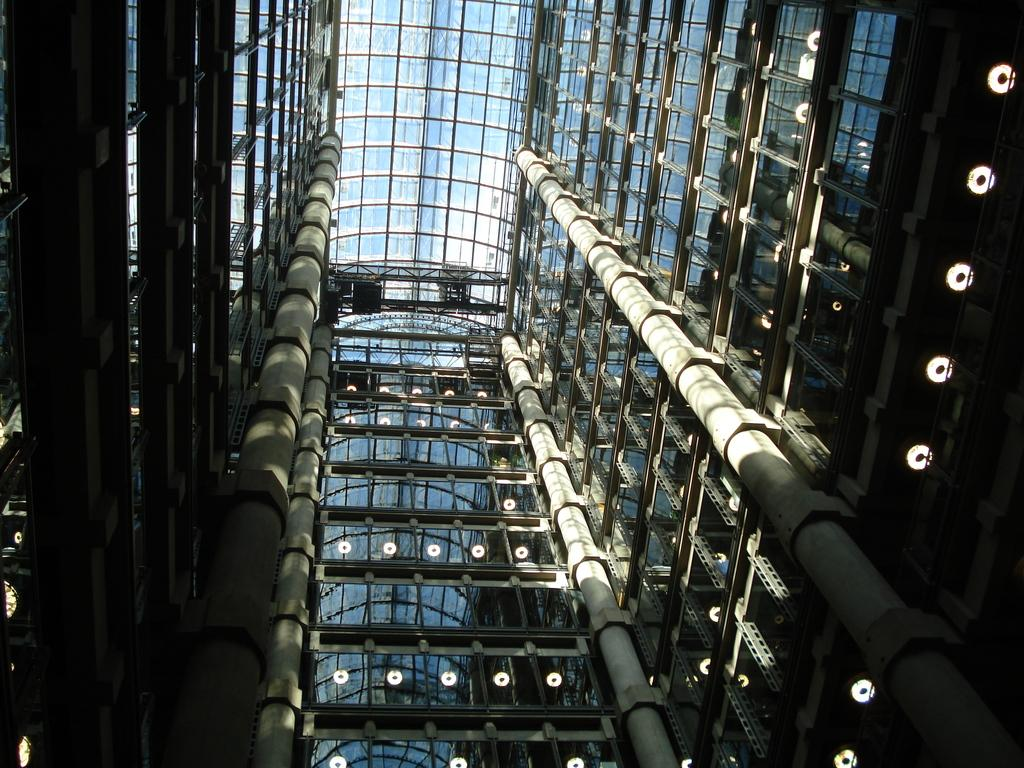What part of a building is shown in the image? The image shows the inner part of a building. What type of windows can be seen in the image? There are glass windows in the image. What can be used to provide illumination in the image? There are lights visible in the image. What type of oatmeal is being served in the image? There is no oatmeal present in the image. Can you tell me how many toys are visible in the image? There are no toys visible in the image. 